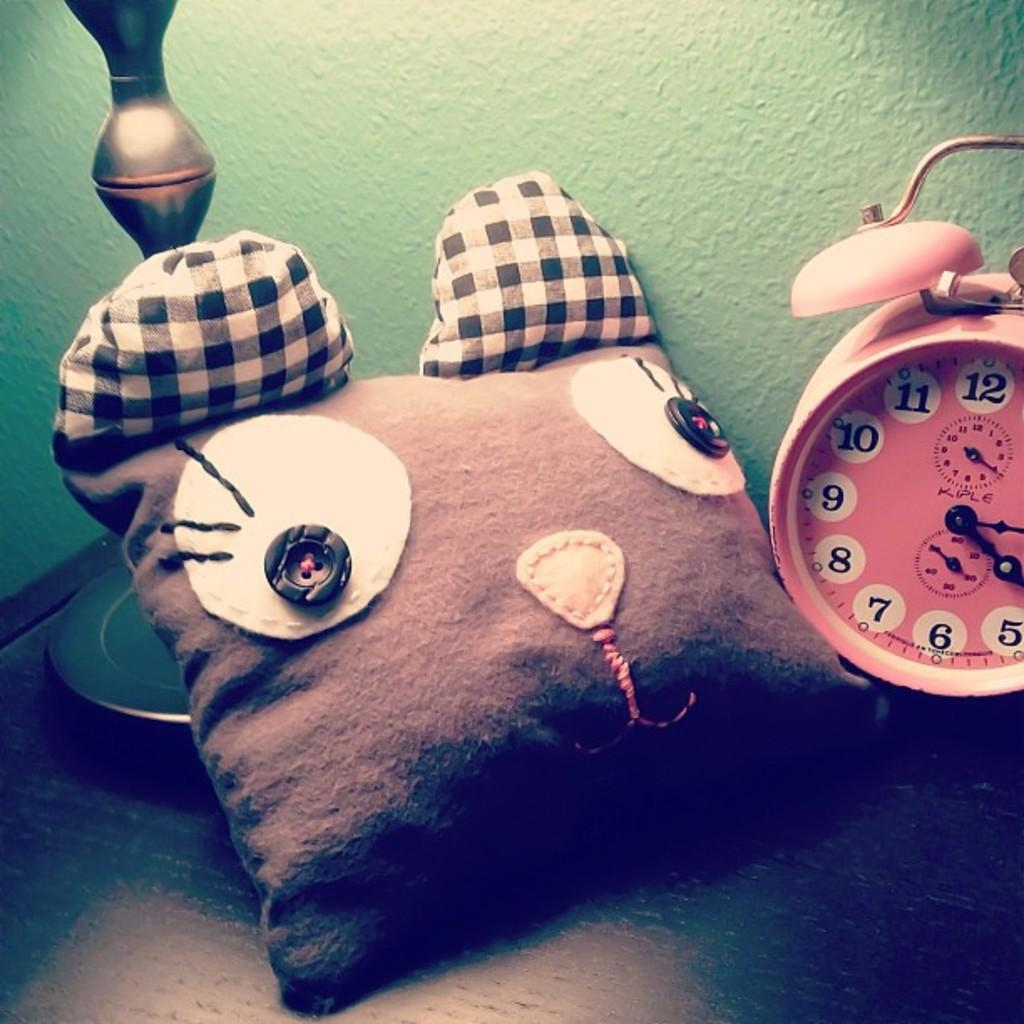Provide a one-sentence caption for the provided image. A cat pillow and a pink Kiple alarm clock are on a table. 